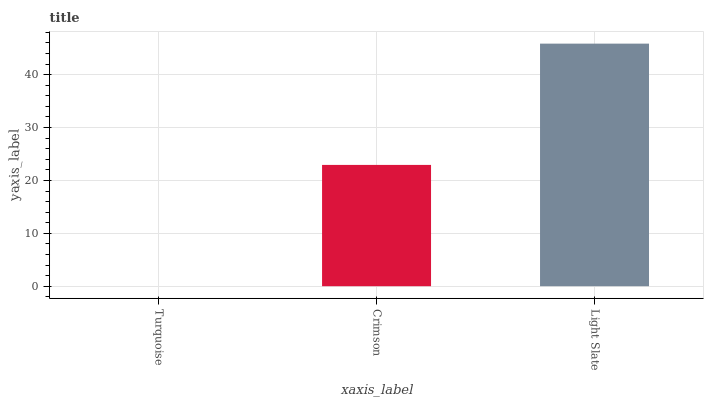Is Turquoise the minimum?
Answer yes or no. Yes. Is Light Slate the maximum?
Answer yes or no. Yes. Is Crimson the minimum?
Answer yes or no. No. Is Crimson the maximum?
Answer yes or no. No. Is Crimson greater than Turquoise?
Answer yes or no. Yes. Is Turquoise less than Crimson?
Answer yes or no. Yes. Is Turquoise greater than Crimson?
Answer yes or no. No. Is Crimson less than Turquoise?
Answer yes or no. No. Is Crimson the high median?
Answer yes or no. Yes. Is Crimson the low median?
Answer yes or no. Yes. Is Turquoise the high median?
Answer yes or no. No. Is Turquoise the low median?
Answer yes or no. No. 